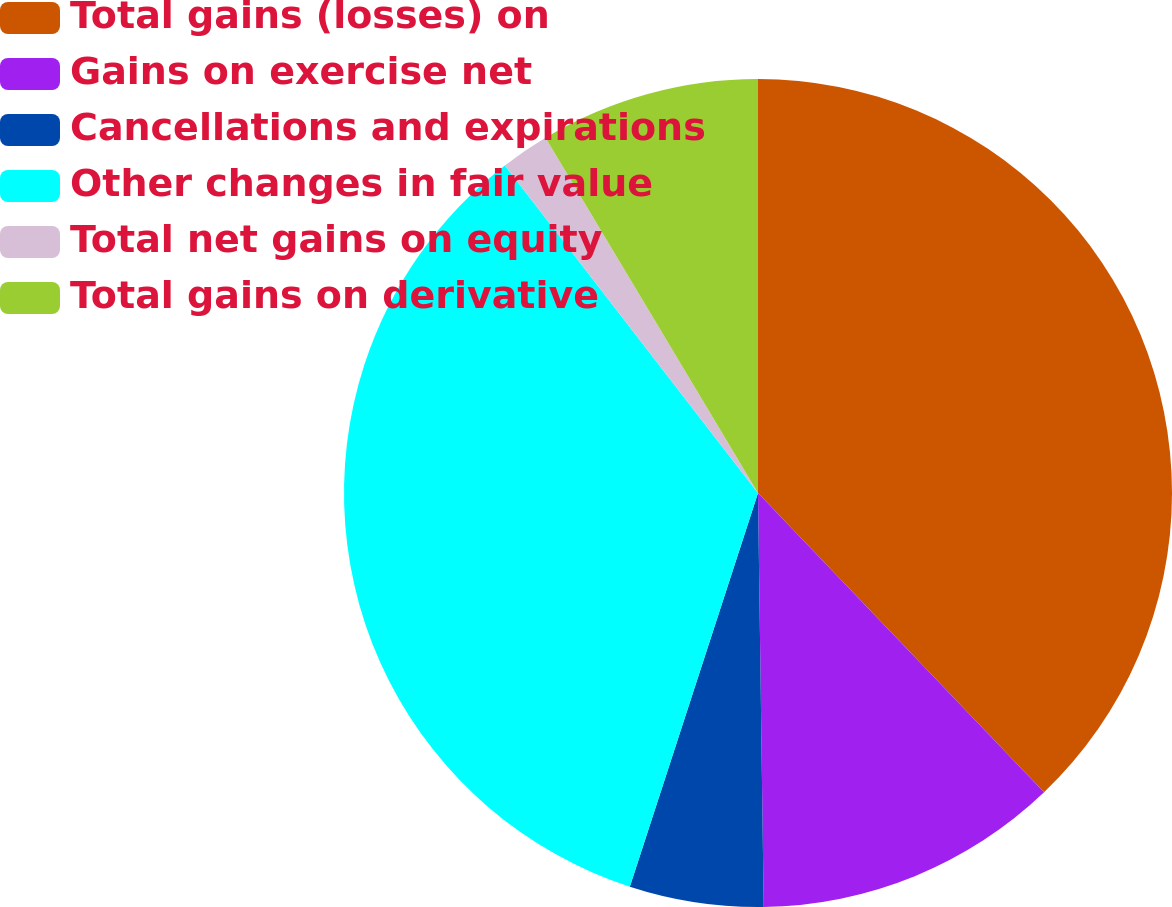Convert chart. <chart><loc_0><loc_0><loc_500><loc_500><pie_chart><fcel>Total gains (losses) on<fcel>Gains on exercise net<fcel>Cancellations and expirations<fcel>Other changes in fair value<fcel>Total net gains on equity<fcel>Total gains on derivative<nl><fcel>37.86%<fcel>11.92%<fcel>5.23%<fcel>34.52%<fcel>1.89%<fcel>8.58%<nl></chart> 